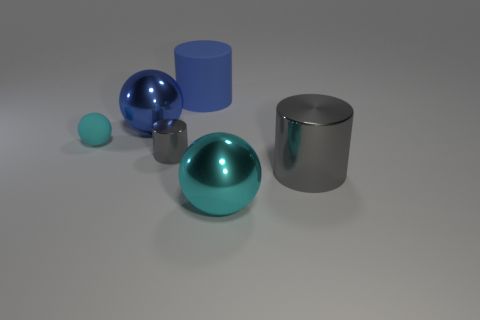Subtract all cyan spheres. How many were subtracted if there are1cyan spheres left? 1 Subtract all tiny cyan spheres. How many spheres are left? 2 Subtract all gray cylinders. How many cylinders are left? 1 Add 3 large shiny things. How many objects exist? 9 Subtract 1 cylinders. How many cylinders are left? 2 Subtract all brown cylinders. Subtract all yellow spheres. How many cylinders are left? 3 Subtract all brown blocks. How many red balls are left? 0 Subtract all cyan rubber spheres. Subtract all tiny gray metal cylinders. How many objects are left? 4 Add 5 spheres. How many spheres are left? 8 Add 4 small balls. How many small balls exist? 5 